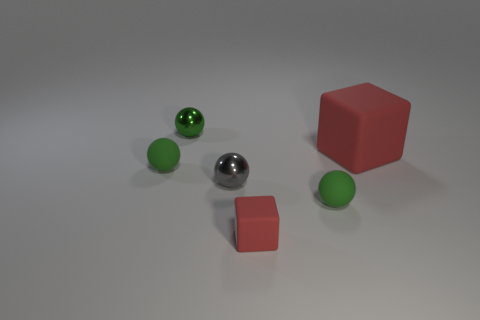There is a small sphere to the right of the gray sphere; what is it made of?
Your answer should be very brief. Rubber. The gray metallic thing that is the same size as the green metal ball is what shape?
Provide a succinct answer. Sphere. Is there a small thing of the same shape as the big red object?
Ensure brevity in your answer.  Yes. Are the tiny gray ball and the small green sphere that is behind the large block made of the same material?
Provide a short and direct response. Yes. There is a tiny gray thing that is in front of the tiny object behind the large red cube; what is it made of?
Your answer should be compact. Metal. Are there more red objects in front of the large red rubber block than blue rubber cylinders?
Provide a short and direct response. Yes. Are there any cyan spheres?
Ensure brevity in your answer.  No. What is the color of the small thing to the right of the tiny red cube?
Your answer should be very brief. Green. What material is the red cube that is the same size as the gray metallic sphere?
Provide a succinct answer. Rubber. What number of other objects are there of the same material as the large red block?
Give a very brief answer. 3. 